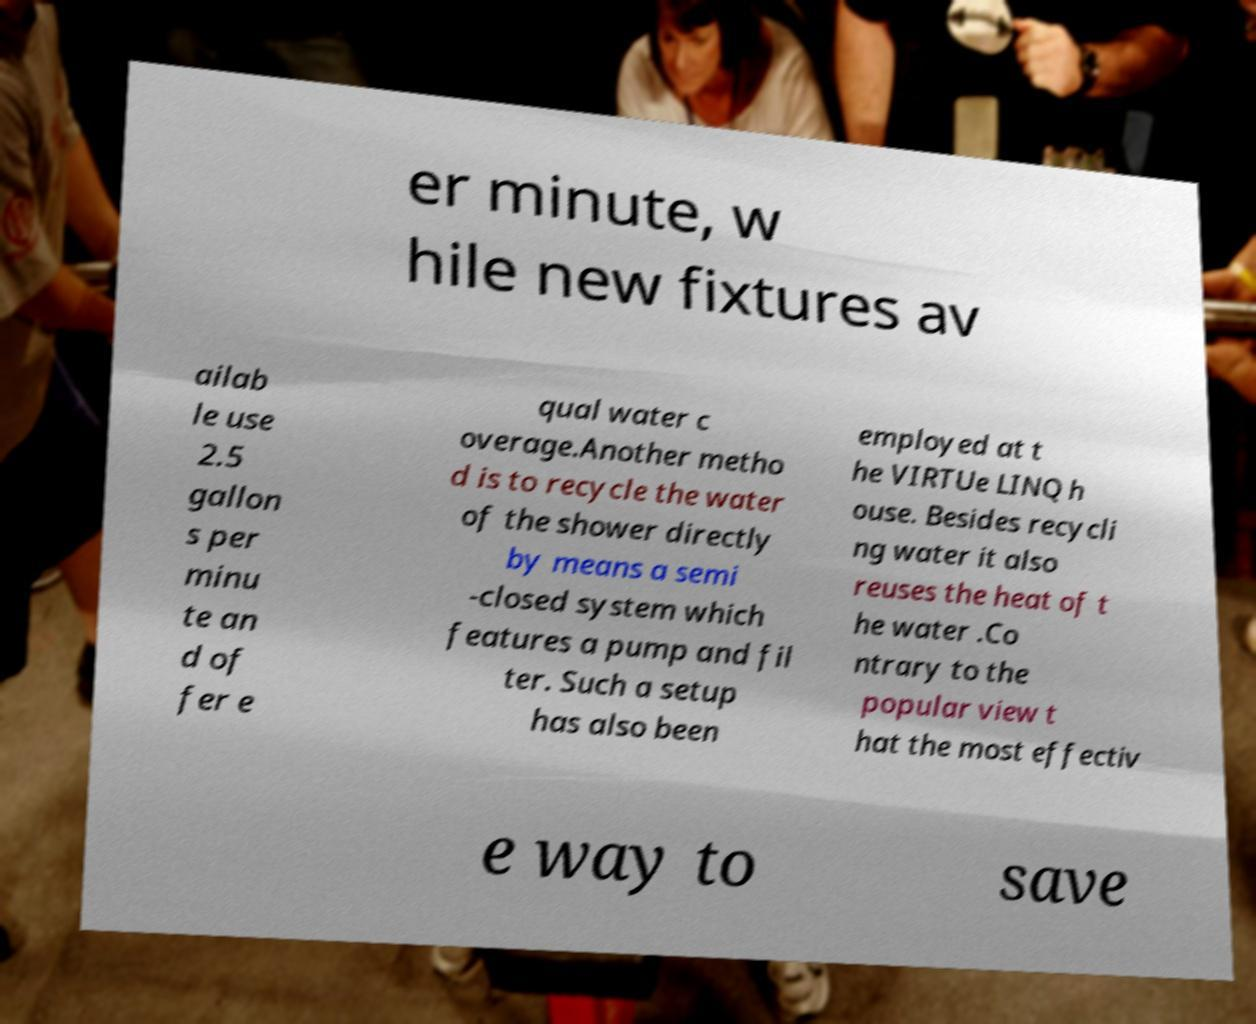Please read and relay the text visible in this image. What does it say? er minute, w hile new fixtures av ailab le use 2.5 gallon s per minu te an d of fer e qual water c overage.Another metho d is to recycle the water of the shower directly by means a semi -closed system which features a pump and fil ter. Such a setup has also been employed at t he VIRTUe LINQ h ouse. Besides recycli ng water it also reuses the heat of t he water .Co ntrary to the popular view t hat the most effectiv e way to save 